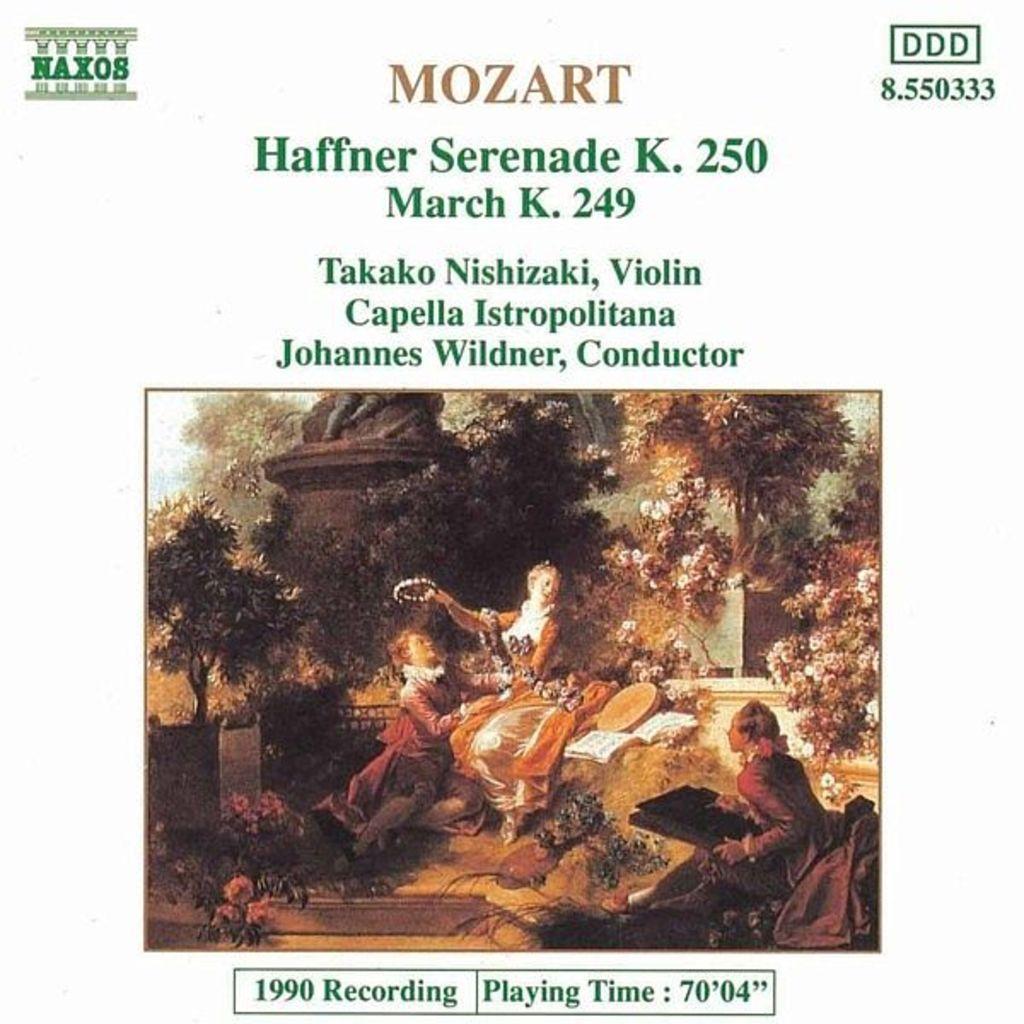Please provide a concise description of this image. In this image we can see a poster on which we can see a image of a few people here, we can see the wall and trees. Here we can see some edited text. 